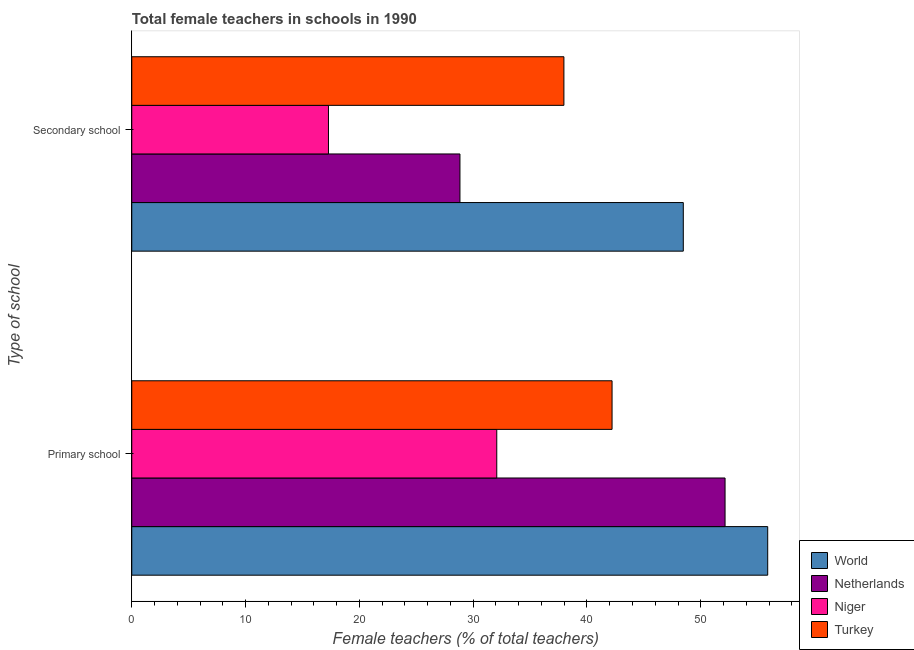How many bars are there on the 1st tick from the top?
Make the answer very short. 4. What is the label of the 2nd group of bars from the top?
Give a very brief answer. Primary school. What is the percentage of female teachers in primary schools in World?
Your response must be concise. 55.88. Across all countries, what is the maximum percentage of female teachers in secondary schools?
Your answer should be very brief. 48.46. Across all countries, what is the minimum percentage of female teachers in primary schools?
Your answer should be very brief. 32.07. In which country was the percentage of female teachers in secondary schools minimum?
Offer a terse response. Niger. What is the total percentage of female teachers in secondary schools in the graph?
Your response must be concise. 132.56. What is the difference between the percentage of female teachers in primary schools in Netherlands and that in Niger?
Offer a terse response. 20.06. What is the difference between the percentage of female teachers in primary schools in Turkey and the percentage of female teachers in secondary schools in Niger?
Make the answer very short. 24.92. What is the average percentage of female teachers in secondary schools per country?
Your answer should be very brief. 33.14. What is the difference between the percentage of female teachers in primary schools and percentage of female teachers in secondary schools in Niger?
Keep it short and to the point. 14.79. What is the ratio of the percentage of female teachers in secondary schools in Niger to that in World?
Provide a succinct answer. 0.36. How many bars are there?
Make the answer very short. 8. Are all the bars in the graph horizontal?
Keep it short and to the point. Yes. Where does the legend appear in the graph?
Your answer should be very brief. Bottom right. How many legend labels are there?
Your answer should be very brief. 4. How are the legend labels stacked?
Make the answer very short. Vertical. What is the title of the graph?
Your response must be concise. Total female teachers in schools in 1990. What is the label or title of the X-axis?
Keep it short and to the point. Female teachers (% of total teachers). What is the label or title of the Y-axis?
Provide a short and direct response. Type of school. What is the Female teachers (% of total teachers) in World in Primary school?
Provide a succinct answer. 55.88. What is the Female teachers (% of total teachers) of Netherlands in Primary school?
Make the answer very short. 52.13. What is the Female teachers (% of total teachers) in Niger in Primary school?
Offer a terse response. 32.07. What is the Female teachers (% of total teachers) of Turkey in Primary school?
Ensure brevity in your answer.  42.2. What is the Female teachers (% of total teachers) of World in Secondary school?
Keep it short and to the point. 48.46. What is the Female teachers (% of total teachers) in Netherlands in Secondary school?
Provide a short and direct response. 28.84. What is the Female teachers (% of total teachers) of Niger in Secondary school?
Give a very brief answer. 17.28. What is the Female teachers (% of total teachers) of Turkey in Secondary school?
Provide a short and direct response. 37.97. Across all Type of school, what is the maximum Female teachers (% of total teachers) in World?
Your answer should be very brief. 55.88. Across all Type of school, what is the maximum Female teachers (% of total teachers) in Netherlands?
Ensure brevity in your answer.  52.13. Across all Type of school, what is the maximum Female teachers (% of total teachers) of Niger?
Your answer should be very brief. 32.07. Across all Type of school, what is the maximum Female teachers (% of total teachers) in Turkey?
Make the answer very short. 42.2. Across all Type of school, what is the minimum Female teachers (% of total teachers) in World?
Offer a very short reply. 48.46. Across all Type of school, what is the minimum Female teachers (% of total teachers) in Netherlands?
Your answer should be very brief. 28.84. Across all Type of school, what is the minimum Female teachers (% of total teachers) of Niger?
Ensure brevity in your answer.  17.28. Across all Type of school, what is the minimum Female teachers (% of total teachers) of Turkey?
Give a very brief answer. 37.97. What is the total Female teachers (% of total teachers) in World in the graph?
Your answer should be compact. 104.34. What is the total Female teachers (% of total teachers) in Netherlands in the graph?
Your response must be concise. 80.97. What is the total Female teachers (% of total teachers) of Niger in the graph?
Ensure brevity in your answer.  49.36. What is the total Female teachers (% of total teachers) of Turkey in the graph?
Ensure brevity in your answer.  80.18. What is the difference between the Female teachers (% of total teachers) in World in Primary school and that in Secondary school?
Provide a short and direct response. 7.42. What is the difference between the Female teachers (% of total teachers) in Netherlands in Primary school and that in Secondary school?
Give a very brief answer. 23.3. What is the difference between the Female teachers (% of total teachers) in Niger in Primary school and that in Secondary school?
Your answer should be compact. 14.79. What is the difference between the Female teachers (% of total teachers) in Turkey in Primary school and that in Secondary school?
Make the answer very short. 4.23. What is the difference between the Female teachers (% of total teachers) of World in Primary school and the Female teachers (% of total teachers) of Netherlands in Secondary school?
Keep it short and to the point. 27.04. What is the difference between the Female teachers (% of total teachers) of World in Primary school and the Female teachers (% of total teachers) of Niger in Secondary school?
Offer a terse response. 38.6. What is the difference between the Female teachers (% of total teachers) of World in Primary school and the Female teachers (% of total teachers) of Turkey in Secondary school?
Your answer should be compact. 17.91. What is the difference between the Female teachers (% of total teachers) of Netherlands in Primary school and the Female teachers (% of total teachers) of Niger in Secondary school?
Keep it short and to the point. 34.85. What is the difference between the Female teachers (% of total teachers) in Netherlands in Primary school and the Female teachers (% of total teachers) in Turkey in Secondary school?
Provide a succinct answer. 14.16. What is the difference between the Female teachers (% of total teachers) of Niger in Primary school and the Female teachers (% of total teachers) of Turkey in Secondary school?
Offer a terse response. -5.9. What is the average Female teachers (% of total teachers) of World per Type of school?
Your answer should be compact. 52.17. What is the average Female teachers (% of total teachers) of Netherlands per Type of school?
Offer a terse response. 40.49. What is the average Female teachers (% of total teachers) of Niger per Type of school?
Your answer should be very brief. 24.68. What is the average Female teachers (% of total teachers) in Turkey per Type of school?
Your response must be concise. 40.09. What is the difference between the Female teachers (% of total teachers) in World and Female teachers (% of total teachers) in Netherlands in Primary school?
Give a very brief answer. 3.75. What is the difference between the Female teachers (% of total teachers) in World and Female teachers (% of total teachers) in Niger in Primary school?
Keep it short and to the point. 23.81. What is the difference between the Female teachers (% of total teachers) in World and Female teachers (% of total teachers) in Turkey in Primary school?
Your response must be concise. 13.68. What is the difference between the Female teachers (% of total teachers) in Netherlands and Female teachers (% of total teachers) in Niger in Primary school?
Offer a very short reply. 20.06. What is the difference between the Female teachers (% of total teachers) of Netherlands and Female teachers (% of total teachers) of Turkey in Primary school?
Offer a very short reply. 9.93. What is the difference between the Female teachers (% of total teachers) of Niger and Female teachers (% of total teachers) of Turkey in Primary school?
Make the answer very short. -10.13. What is the difference between the Female teachers (% of total teachers) of World and Female teachers (% of total teachers) of Netherlands in Secondary school?
Ensure brevity in your answer.  19.63. What is the difference between the Female teachers (% of total teachers) of World and Female teachers (% of total teachers) of Niger in Secondary school?
Your answer should be compact. 31.18. What is the difference between the Female teachers (% of total teachers) in World and Female teachers (% of total teachers) in Turkey in Secondary school?
Ensure brevity in your answer.  10.49. What is the difference between the Female teachers (% of total teachers) of Netherlands and Female teachers (% of total teachers) of Niger in Secondary school?
Provide a short and direct response. 11.55. What is the difference between the Female teachers (% of total teachers) of Netherlands and Female teachers (% of total teachers) of Turkey in Secondary school?
Your answer should be compact. -9.14. What is the difference between the Female teachers (% of total teachers) in Niger and Female teachers (% of total teachers) in Turkey in Secondary school?
Your response must be concise. -20.69. What is the ratio of the Female teachers (% of total teachers) of World in Primary school to that in Secondary school?
Provide a short and direct response. 1.15. What is the ratio of the Female teachers (% of total teachers) in Netherlands in Primary school to that in Secondary school?
Your answer should be compact. 1.81. What is the ratio of the Female teachers (% of total teachers) of Niger in Primary school to that in Secondary school?
Provide a short and direct response. 1.86. What is the ratio of the Female teachers (% of total teachers) of Turkey in Primary school to that in Secondary school?
Make the answer very short. 1.11. What is the difference between the highest and the second highest Female teachers (% of total teachers) of World?
Provide a short and direct response. 7.42. What is the difference between the highest and the second highest Female teachers (% of total teachers) in Netherlands?
Ensure brevity in your answer.  23.3. What is the difference between the highest and the second highest Female teachers (% of total teachers) in Niger?
Offer a terse response. 14.79. What is the difference between the highest and the second highest Female teachers (% of total teachers) of Turkey?
Ensure brevity in your answer.  4.23. What is the difference between the highest and the lowest Female teachers (% of total teachers) of World?
Your answer should be compact. 7.42. What is the difference between the highest and the lowest Female teachers (% of total teachers) of Netherlands?
Give a very brief answer. 23.3. What is the difference between the highest and the lowest Female teachers (% of total teachers) of Niger?
Your answer should be compact. 14.79. What is the difference between the highest and the lowest Female teachers (% of total teachers) in Turkey?
Offer a terse response. 4.23. 